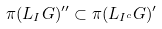Convert formula to latex. <formula><loc_0><loc_0><loc_500><loc_500>\pi ( L _ { I } G ) ^ { \prime \prime } \subset \pi ( L _ { I ^ { c } } G ) ^ { \prime }</formula> 